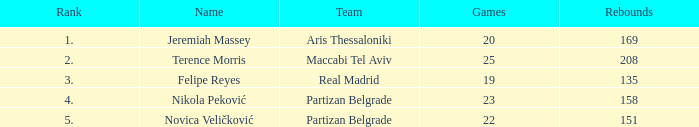For partizan belgrade's nikola peković, what is the count of games played with a ranking above 4? None. 